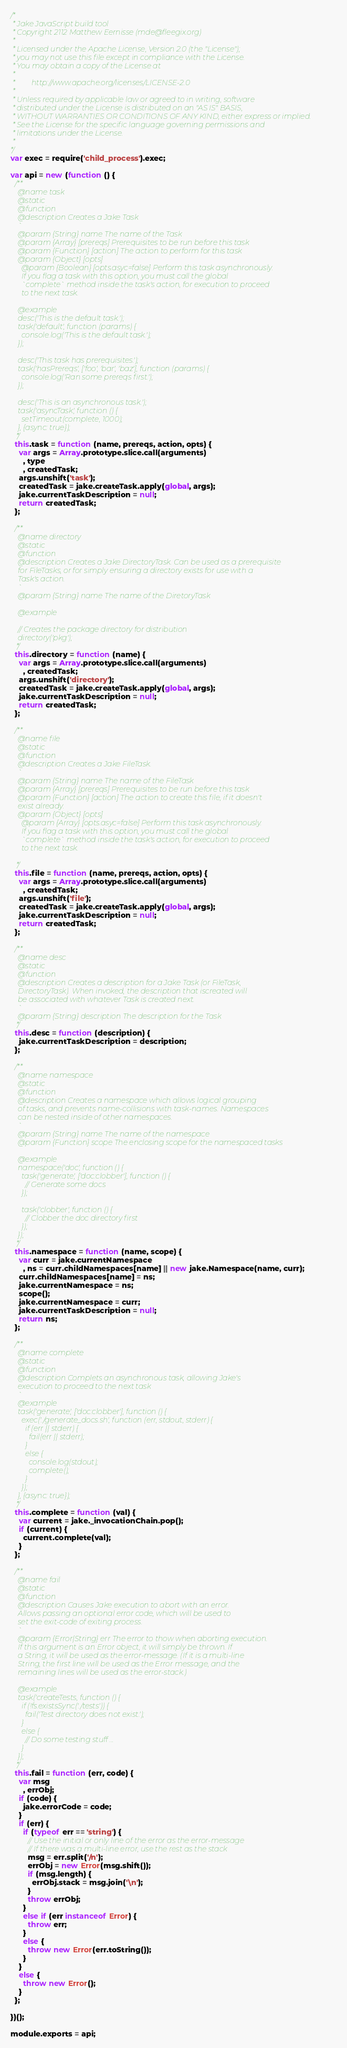Convert code to text. <code><loc_0><loc_0><loc_500><loc_500><_JavaScript_>/*
 * Jake JavaScript build tool
 * Copyright 2112 Matthew Eernisse (mde@fleegix.org)
 *
 * Licensed under the Apache License, Version 2.0 (the "License");
 * you may not use this file except in compliance with the License.
 * You may obtain a copy of the License at
 *
 *         http://www.apache.org/licenses/LICENSE-2.0
 *
 * Unless required by applicable law or agreed to in writing, software
 * distributed under the License is distributed on an "AS IS" BASIS,
 * WITHOUT WARRANTIES OR CONDITIONS OF ANY KIND, either express or implied.
 * See the License for the specific language governing permissions and
 * limitations under the License.
 *
*/
var exec = require('child_process').exec;

var api = new (function () {
  /**
    @name task
    @static
    @function
    @description Creates a Jake Task
    `
    @param {String} name The name of the Task
    @param {Array} [prereqs] Prerequisites to be run before this task
    @param {Function} [action] The action to perform for this task
    @param {Object} [opts]
      @param {Boolean} [opts.asyc=false] Perform this task asynchronously.
      If you flag a task with this option, you must call the global
      `complete` method inside the task's action, for execution to proceed
      to the next task.

    @example
    desc('This is the default task.');
    task('default', function (params) {
      console.log('This is the default task.');
    });

    desc('This task has prerequisites.');
    task('hasPrereqs', ['foo', 'bar', 'baz'], function (params) {
      console.log('Ran some prereqs first.');
    });

    desc('This is an asynchronous task.');
    task('asyncTask', function () {
      setTimeout(complete, 1000);
    }, {async: true});
   */
  this.task = function (name, prereqs, action, opts) {
    var args = Array.prototype.slice.call(arguments)
      , type
      , createdTask;
    args.unshift('task');
    createdTask = jake.createTask.apply(global, args);
    jake.currentTaskDescription = null;
    return createdTask;
  };

  /**
    @name directory
    @static
    @function
    @description Creates a Jake DirectoryTask. Can be used as a prerequisite
    for FileTasks, or for simply ensuring a directory exists for use with a
    Task's action.
    `
    @param {String} name The name of the DiretoryTask

    @example

    // Creates the package directory for distribution
    directory('pkg');
   */
  this.directory = function (name) {
    var args = Array.prototype.slice.call(arguments)
      , createdTask;
    args.unshift('directory');
    createdTask = jake.createTask.apply(global, args);
    jake.currentTaskDescription = null;
    return createdTask;
  };

  /**
    @name file
    @static
    @function
    @description Creates a Jake FileTask.
    `
    @param {String} name The name of the FileTask
    @param {Array} [prereqs] Prerequisites to be run before this task
    @param {Function} [action] The action to create this file, if it doesn't
    exist already.
    @param {Object} [opts]
      @param {Array} [opts.asyc=false] Perform this task asynchronously.
      If you flag a task with this option, you must call the global
      `complete` method inside the task's action, for execution to proceed
      to the next task.

   */
  this.file = function (name, prereqs, action, opts) {
    var args = Array.prototype.slice.call(arguments)
      , createdTask;
    args.unshift('file');
    createdTask = jake.createTask.apply(global, args);
    jake.currentTaskDescription = null;
    return createdTask;
  };

  /**
    @name desc
    @static
    @function
    @description Creates a description for a Jake Task (or FileTask,
    DirectoryTask). When invoked, the description that iscreated will
    be associated with whatever Task is created next.
    `
    @param {String} description The description for the Task
   */
  this.desc = function (description) {
    jake.currentTaskDescription = description;
  };

  /**
    @name namespace
    @static
    @function
    @description Creates a namespace which allows logical grouping
    of tasks, and prevents name-collisions with task-names. Namespaces
    can be nested inside of other namespaces.
    `
    @param {String} name The name of the namespace
    @param {Function} scope The enclosing scope for the namespaced tasks

    @example
    namespace('doc', function () {
      task('generate', ['doc:clobber'], function () {
        // Generate some docs
      });

      task('clobber', function () {
        // Clobber the doc directory first
      });
    });
   */
  this.namespace = function (name, scope) {
    var curr = jake.currentNamespace
      , ns = curr.childNamespaces[name] || new jake.Namespace(name, curr);
    curr.childNamespaces[name] = ns;
    jake.currentNamespace = ns;
    scope();
    jake.currentNamespace = curr;
    jake.currentTaskDescription = null;
    return ns;
  };

  /**
    @name complete
    @static
    @function
    @description Complets an asynchronous task, allowing Jake's
    execution to proceed to the next task
    `
    @example
    task('generate', ['doc:clobber'], function () {
      exec('./generate_docs.sh', function (err, stdout, stderr) {
        if (err || stderr) {
          fail(err || stderr);
        }
        else {
          console.log(stdout);
          complete();
        }
      });
    }, {async: true});
   */
  this.complete = function (val) {
    var current = jake._invocationChain.pop();
    if (current) {
      current.complete(val);
    }
  };

  /**
    @name fail
    @static
    @function
    @description Causes Jake execution to abort with an error.
    Allows passing an optional error code, which will be used to
    set the exit-code of exiting process.
    `
    @param {Error|String} err The error to thow when aborting execution.
    If this argument is an Error object, it will simply be thrown. If
    a String, it will be used as the error-message. (If it is a multi-line
    String, the first line will be used as the Error message, and the
    remaining lines will be used as the error-stack.)

    @example
    task('createTests, function () {
      if (!fs.existsSync('./tests')) {
        fail('Test directory does not exist.');
      }
      else {
        // Do some testing stuff ...
      }
    });
   */
  this.fail = function (err, code) {
    var msg
      , errObj;
    if (code) {
      jake.errorCode = code;
    }
    if (err) {
      if (typeof err == 'string') {
        // Use the initial or only line of the error as the error-message
        // If there was a multi-line error, use the rest as the stack
        msg = err.split('/n');
        errObj = new Error(msg.shift());
        if (msg.length) {
          errObj.stack = msg.join('\n');
        }
        throw errObj;
      }
      else if (err instanceof Error) {
        throw err;
      }
      else {
        throw new Error(err.toString());
      }
    }
    else {
      throw new Error();
    }
  };

})();

module.exports = api;
</code> 